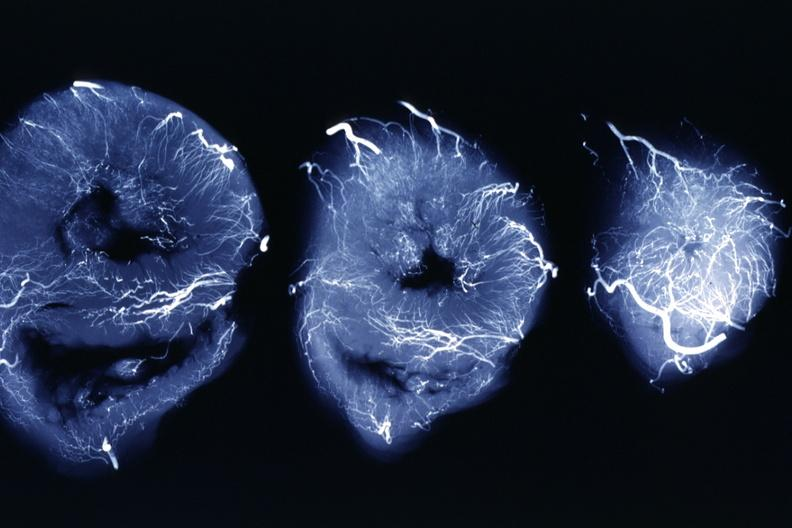what is x-ray intramyocardial arteries?
Answer the question using a single word or phrase. Arteries present 